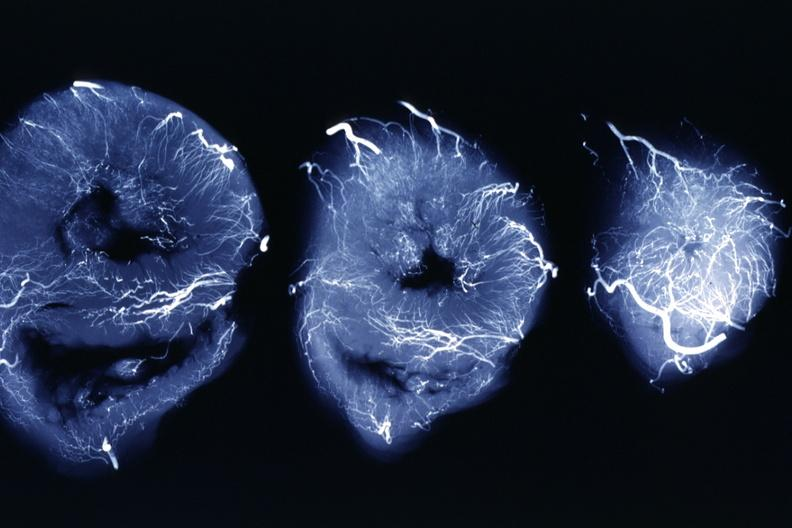what is x-ray intramyocardial arteries?
Answer the question using a single word or phrase. Arteries present 